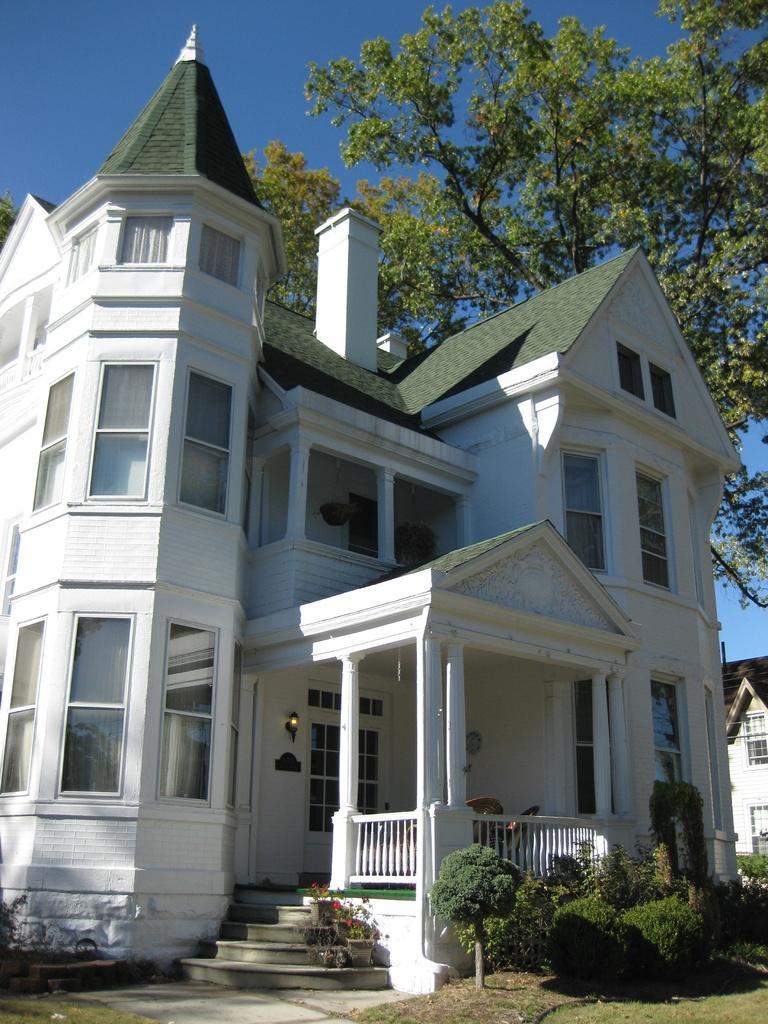Describe this image in one or two sentences. In this image, there are a few buildings. We can see the ground with some objects. We can also see some grass, plants and trees. We can also see the sky. We can see some stairs. 